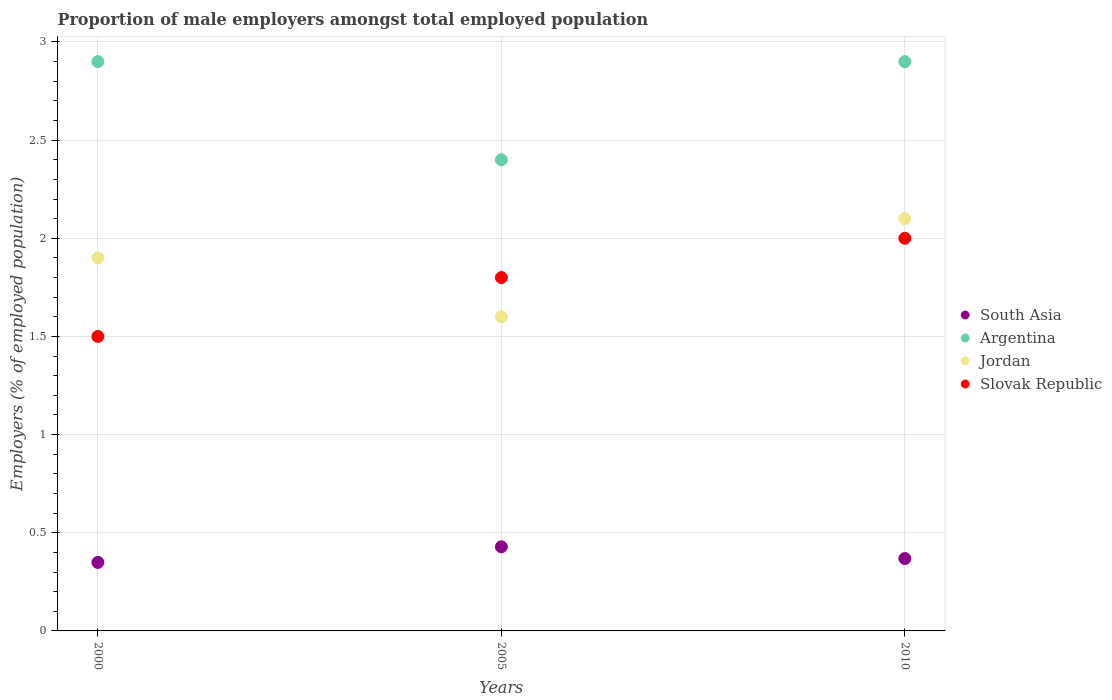How many different coloured dotlines are there?
Provide a succinct answer. 4. What is the proportion of male employers in South Asia in 2000?
Make the answer very short. 0.35. Across all years, what is the maximum proportion of male employers in South Asia?
Give a very brief answer. 0.43. Across all years, what is the minimum proportion of male employers in Argentina?
Your answer should be very brief. 2.4. In which year was the proportion of male employers in Jordan maximum?
Provide a short and direct response. 2010. What is the total proportion of male employers in Argentina in the graph?
Offer a very short reply. 8.2. What is the difference between the proportion of male employers in Slovak Republic in 2005 and the proportion of male employers in South Asia in 2010?
Your response must be concise. 1.43. What is the average proportion of male employers in Slovak Republic per year?
Give a very brief answer. 1.77. In the year 2010, what is the difference between the proportion of male employers in Slovak Republic and proportion of male employers in South Asia?
Provide a succinct answer. 1.63. What is the ratio of the proportion of male employers in Argentina in 2000 to that in 2005?
Make the answer very short. 1.21. What is the difference between the highest and the second highest proportion of male employers in Jordan?
Ensure brevity in your answer.  0.2. What is the difference between the highest and the lowest proportion of male employers in Jordan?
Keep it short and to the point. 0.5. Is it the case that in every year, the sum of the proportion of male employers in Argentina and proportion of male employers in South Asia  is greater than the sum of proportion of male employers in Slovak Republic and proportion of male employers in Jordan?
Offer a very short reply. Yes. Is it the case that in every year, the sum of the proportion of male employers in Slovak Republic and proportion of male employers in Jordan  is greater than the proportion of male employers in Argentina?
Give a very brief answer. Yes. Is the proportion of male employers in Jordan strictly greater than the proportion of male employers in Argentina over the years?
Provide a succinct answer. No. How many dotlines are there?
Offer a terse response. 4. What is the difference between two consecutive major ticks on the Y-axis?
Your answer should be compact. 0.5. Does the graph contain grids?
Keep it short and to the point. Yes. How are the legend labels stacked?
Keep it short and to the point. Vertical. What is the title of the graph?
Give a very brief answer. Proportion of male employers amongst total employed population. What is the label or title of the X-axis?
Ensure brevity in your answer.  Years. What is the label or title of the Y-axis?
Make the answer very short. Employers (% of employed population). What is the Employers (% of employed population) of South Asia in 2000?
Offer a terse response. 0.35. What is the Employers (% of employed population) of Argentina in 2000?
Offer a very short reply. 2.9. What is the Employers (% of employed population) of Jordan in 2000?
Offer a terse response. 1.9. What is the Employers (% of employed population) of South Asia in 2005?
Keep it short and to the point. 0.43. What is the Employers (% of employed population) of Argentina in 2005?
Give a very brief answer. 2.4. What is the Employers (% of employed population) of Jordan in 2005?
Make the answer very short. 1.6. What is the Employers (% of employed population) of Slovak Republic in 2005?
Your answer should be compact. 1.8. What is the Employers (% of employed population) in South Asia in 2010?
Your answer should be very brief. 0.37. What is the Employers (% of employed population) in Argentina in 2010?
Give a very brief answer. 2.9. What is the Employers (% of employed population) of Jordan in 2010?
Keep it short and to the point. 2.1. Across all years, what is the maximum Employers (% of employed population) in South Asia?
Give a very brief answer. 0.43. Across all years, what is the maximum Employers (% of employed population) of Argentina?
Offer a very short reply. 2.9. Across all years, what is the maximum Employers (% of employed population) in Jordan?
Your answer should be compact. 2.1. Across all years, what is the maximum Employers (% of employed population) in Slovak Republic?
Ensure brevity in your answer.  2. Across all years, what is the minimum Employers (% of employed population) of South Asia?
Keep it short and to the point. 0.35. Across all years, what is the minimum Employers (% of employed population) in Argentina?
Offer a very short reply. 2.4. Across all years, what is the minimum Employers (% of employed population) in Jordan?
Provide a succinct answer. 1.6. Across all years, what is the minimum Employers (% of employed population) in Slovak Republic?
Provide a short and direct response. 1.5. What is the total Employers (% of employed population) of South Asia in the graph?
Make the answer very short. 1.15. What is the total Employers (% of employed population) of Argentina in the graph?
Keep it short and to the point. 8.2. What is the total Employers (% of employed population) in Jordan in the graph?
Offer a very short reply. 5.6. What is the total Employers (% of employed population) in Slovak Republic in the graph?
Give a very brief answer. 5.3. What is the difference between the Employers (% of employed population) in South Asia in 2000 and that in 2005?
Ensure brevity in your answer.  -0.08. What is the difference between the Employers (% of employed population) of Jordan in 2000 and that in 2005?
Your answer should be compact. 0.3. What is the difference between the Employers (% of employed population) in South Asia in 2000 and that in 2010?
Make the answer very short. -0.02. What is the difference between the Employers (% of employed population) in South Asia in 2005 and that in 2010?
Provide a succinct answer. 0.06. What is the difference between the Employers (% of employed population) in Argentina in 2005 and that in 2010?
Keep it short and to the point. -0.5. What is the difference between the Employers (% of employed population) in Jordan in 2005 and that in 2010?
Offer a very short reply. -0.5. What is the difference between the Employers (% of employed population) of Slovak Republic in 2005 and that in 2010?
Provide a short and direct response. -0.2. What is the difference between the Employers (% of employed population) of South Asia in 2000 and the Employers (% of employed population) of Argentina in 2005?
Your response must be concise. -2.05. What is the difference between the Employers (% of employed population) in South Asia in 2000 and the Employers (% of employed population) in Jordan in 2005?
Offer a very short reply. -1.25. What is the difference between the Employers (% of employed population) of South Asia in 2000 and the Employers (% of employed population) of Slovak Republic in 2005?
Offer a very short reply. -1.45. What is the difference between the Employers (% of employed population) of Argentina in 2000 and the Employers (% of employed population) of Jordan in 2005?
Make the answer very short. 1.3. What is the difference between the Employers (% of employed population) of Jordan in 2000 and the Employers (% of employed population) of Slovak Republic in 2005?
Give a very brief answer. 0.1. What is the difference between the Employers (% of employed population) in South Asia in 2000 and the Employers (% of employed population) in Argentina in 2010?
Offer a terse response. -2.55. What is the difference between the Employers (% of employed population) of South Asia in 2000 and the Employers (% of employed population) of Jordan in 2010?
Provide a short and direct response. -1.75. What is the difference between the Employers (% of employed population) in South Asia in 2000 and the Employers (% of employed population) in Slovak Republic in 2010?
Your answer should be very brief. -1.65. What is the difference between the Employers (% of employed population) of South Asia in 2005 and the Employers (% of employed population) of Argentina in 2010?
Ensure brevity in your answer.  -2.47. What is the difference between the Employers (% of employed population) in South Asia in 2005 and the Employers (% of employed population) in Jordan in 2010?
Your response must be concise. -1.67. What is the difference between the Employers (% of employed population) of South Asia in 2005 and the Employers (% of employed population) of Slovak Republic in 2010?
Ensure brevity in your answer.  -1.57. What is the difference between the Employers (% of employed population) in Argentina in 2005 and the Employers (% of employed population) in Slovak Republic in 2010?
Make the answer very short. 0.4. What is the average Employers (% of employed population) in South Asia per year?
Make the answer very short. 0.38. What is the average Employers (% of employed population) of Argentina per year?
Provide a short and direct response. 2.73. What is the average Employers (% of employed population) in Jordan per year?
Your response must be concise. 1.87. What is the average Employers (% of employed population) in Slovak Republic per year?
Keep it short and to the point. 1.77. In the year 2000, what is the difference between the Employers (% of employed population) in South Asia and Employers (% of employed population) in Argentina?
Make the answer very short. -2.55. In the year 2000, what is the difference between the Employers (% of employed population) of South Asia and Employers (% of employed population) of Jordan?
Provide a short and direct response. -1.55. In the year 2000, what is the difference between the Employers (% of employed population) in South Asia and Employers (% of employed population) in Slovak Republic?
Offer a very short reply. -1.15. In the year 2000, what is the difference between the Employers (% of employed population) in Argentina and Employers (% of employed population) in Slovak Republic?
Provide a succinct answer. 1.4. In the year 2000, what is the difference between the Employers (% of employed population) in Jordan and Employers (% of employed population) in Slovak Republic?
Your response must be concise. 0.4. In the year 2005, what is the difference between the Employers (% of employed population) of South Asia and Employers (% of employed population) of Argentina?
Keep it short and to the point. -1.97. In the year 2005, what is the difference between the Employers (% of employed population) in South Asia and Employers (% of employed population) in Jordan?
Your response must be concise. -1.17. In the year 2005, what is the difference between the Employers (% of employed population) of South Asia and Employers (% of employed population) of Slovak Republic?
Your response must be concise. -1.37. In the year 2005, what is the difference between the Employers (% of employed population) of Argentina and Employers (% of employed population) of Slovak Republic?
Make the answer very short. 0.6. In the year 2010, what is the difference between the Employers (% of employed population) of South Asia and Employers (% of employed population) of Argentina?
Your answer should be very brief. -2.53. In the year 2010, what is the difference between the Employers (% of employed population) of South Asia and Employers (% of employed population) of Jordan?
Provide a succinct answer. -1.73. In the year 2010, what is the difference between the Employers (% of employed population) in South Asia and Employers (% of employed population) in Slovak Republic?
Ensure brevity in your answer.  -1.63. In the year 2010, what is the difference between the Employers (% of employed population) in Jordan and Employers (% of employed population) in Slovak Republic?
Offer a very short reply. 0.1. What is the ratio of the Employers (% of employed population) of South Asia in 2000 to that in 2005?
Provide a succinct answer. 0.81. What is the ratio of the Employers (% of employed population) in Argentina in 2000 to that in 2005?
Provide a succinct answer. 1.21. What is the ratio of the Employers (% of employed population) of Jordan in 2000 to that in 2005?
Provide a succinct answer. 1.19. What is the ratio of the Employers (% of employed population) in South Asia in 2000 to that in 2010?
Your answer should be compact. 0.95. What is the ratio of the Employers (% of employed population) of Jordan in 2000 to that in 2010?
Your answer should be compact. 0.9. What is the ratio of the Employers (% of employed population) of Slovak Republic in 2000 to that in 2010?
Your answer should be compact. 0.75. What is the ratio of the Employers (% of employed population) in South Asia in 2005 to that in 2010?
Provide a short and direct response. 1.16. What is the ratio of the Employers (% of employed population) of Argentina in 2005 to that in 2010?
Provide a succinct answer. 0.83. What is the ratio of the Employers (% of employed population) in Jordan in 2005 to that in 2010?
Provide a short and direct response. 0.76. What is the difference between the highest and the second highest Employers (% of employed population) in South Asia?
Provide a succinct answer. 0.06. What is the difference between the highest and the second highest Employers (% of employed population) in Argentina?
Make the answer very short. 0. What is the difference between the highest and the second highest Employers (% of employed population) of Jordan?
Provide a short and direct response. 0.2. What is the difference between the highest and the second highest Employers (% of employed population) in Slovak Republic?
Ensure brevity in your answer.  0.2. What is the difference between the highest and the lowest Employers (% of employed population) in South Asia?
Keep it short and to the point. 0.08. What is the difference between the highest and the lowest Employers (% of employed population) in Argentina?
Provide a short and direct response. 0.5. 